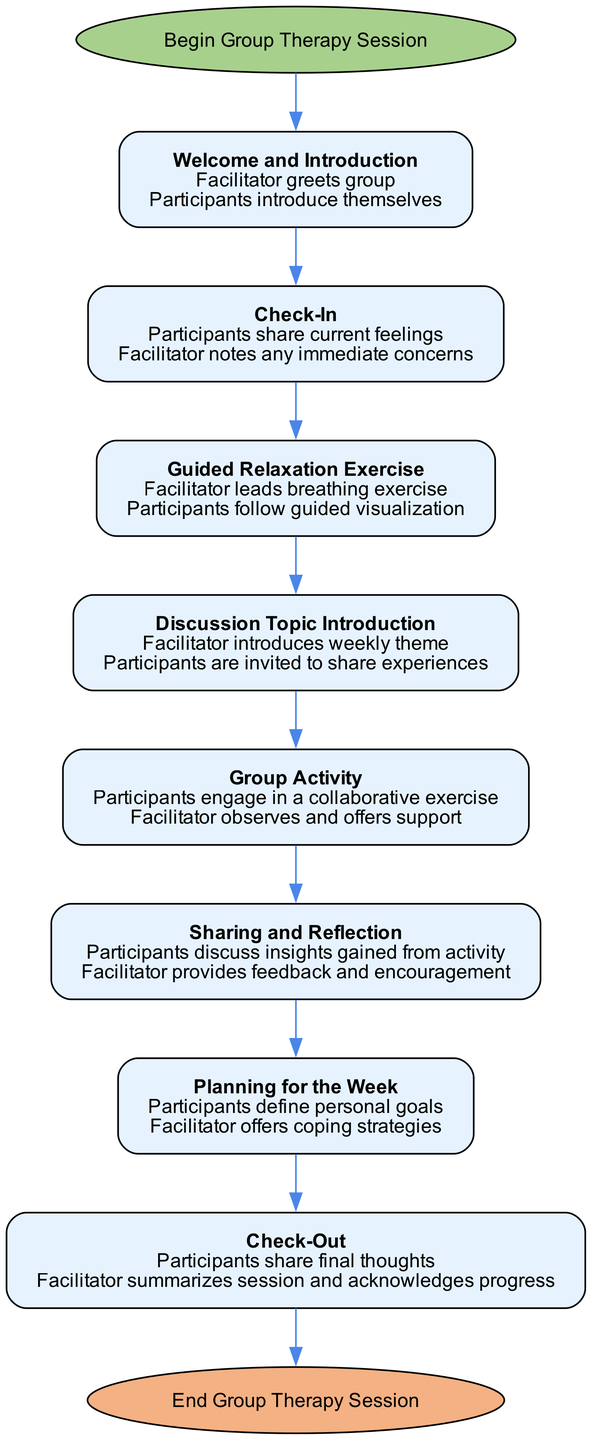What is the first activity in the group therapy session? The first activity in the diagram is identified as "Welcome and Introduction," which is the first step after the starting point labeled "Begin Group Therapy Session."
Answer: Welcome and Introduction How many activities are there in the session? By counting the separate activities listed under the "steps" section, there are a total of 8 activities from "Welcome and Introduction" to "Check-Out."
Answer: 8 What is the last activity before the end of the session? The last activity indicated in the diagram before reaching the endpoint "End Group Therapy Session" is "Check-Out," which connects directly to the end node.
Answer: Check-Out Which activity comes immediately after "Guided Relaxation Exercise"? According to the diagram's flow, "Discussion Topic Introduction" follows directly after "Guided Relaxation Exercise," making it the immediate next activity.
Answer: Discussion Topic Introduction What are the two actions taken during the "Check-In" activity? The actions during "Check-In" are: "Participants share current feelings" and "Facilitator notes any immediate concerns," which are specifically listed under that activity in the diagram.
Answer: Participants share current feelings, Facilitator notes any immediate concerns What is the purpose of the "Planning for the Week" activity? The "Planning for the Week" activity serves to help participants define personal goals and allows the facilitator to offer coping strategies, as illustrated in the diagram with its specified actions.
Answer: Define personal goals, offer coping strategies Which activity is described as a collaborative exercise? The activity referred to as a collaborative exercise is "Group Activity," where participants engage in teamwork while the facilitator observes and offers support.
Answer: Group Activity What does the facilitator do during the "Sharing and Reflection" activity? During "Sharing and Reflection," the facilitator provides feedback and encouragement based on the discussions and insights shared by the participants about their experiences.
Answer: Provides feedback and encouragement 